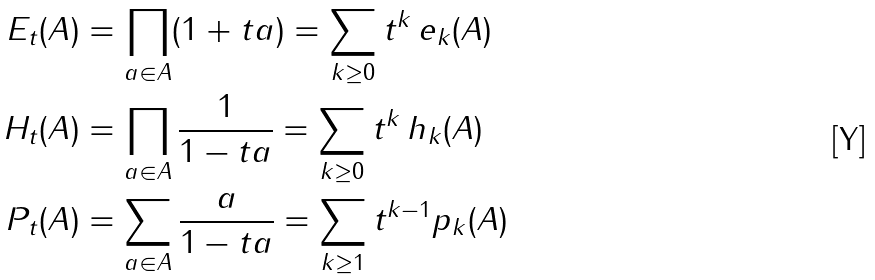<formula> <loc_0><loc_0><loc_500><loc_500>E _ { t } ( A ) & = \prod _ { a \in A } ( 1 + t a ) = \sum _ { k \geq 0 } t ^ { k } \, e _ { k } ( A ) \\ H _ { t } ( A ) & = \prod _ { a \in A } \frac { 1 } { 1 - t a } = \sum _ { k \geq 0 } t ^ { k } \, h _ { k } ( A ) \\ P _ { t } ( A ) & = \sum _ { a \in A } \frac { a } { 1 - t a } = \sum _ { k \geq 1 } t ^ { k - 1 } p _ { k } ( A )</formula> 